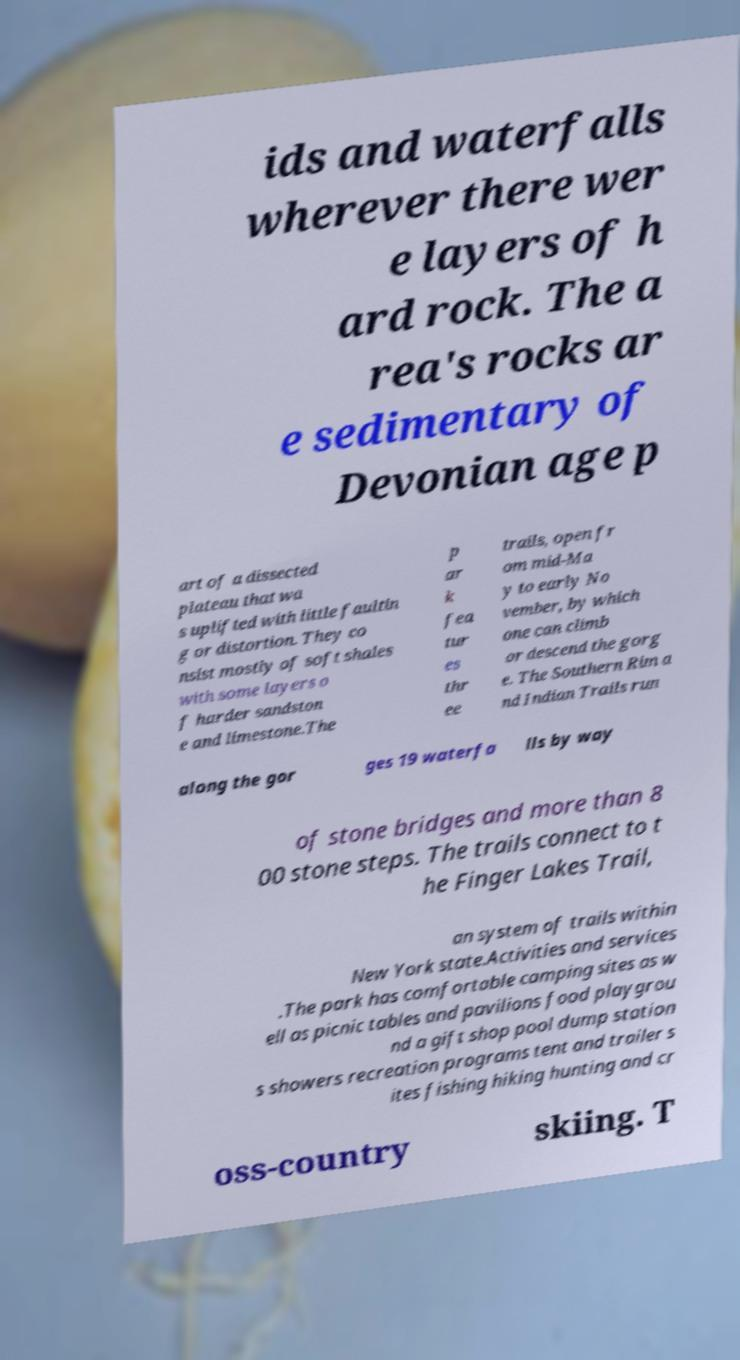Can you read and provide the text displayed in the image?This photo seems to have some interesting text. Can you extract and type it out for me? ids and waterfalls wherever there wer e layers of h ard rock. The a rea's rocks ar e sedimentary of Devonian age p art of a dissected plateau that wa s uplifted with little faultin g or distortion. They co nsist mostly of soft shales with some layers o f harder sandston e and limestone.The p ar k fea tur es thr ee trails, open fr om mid-Ma y to early No vember, by which one can climb or descend the gorg e. The Southern Rim a nd Indian Trails run along the gor ges 19 waterfa lls by way of stone bridges and more than 8 00 stone steps. The trails connect to t he Finger Lakes Trail, an system of trails within New York state.Activities and services .The park has comfortable camping sites as w ell as picnic tables and pavilions food playgrou nd a gift shop pool dump station s showers recreation programs tent and trailer s ites fishing hiking hunting and cr oss-country skiing. T 